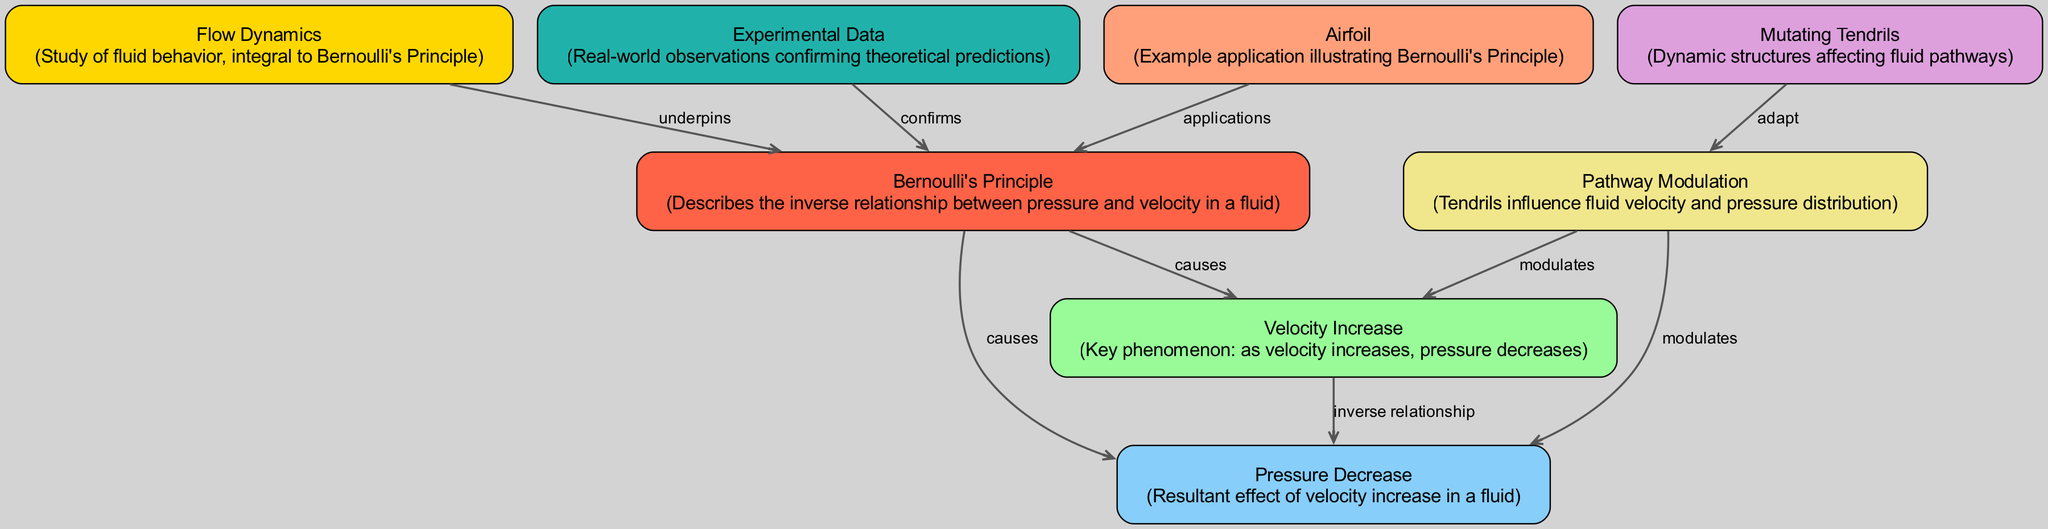What is the central concept illustrated by this diagram? The central concept is "Bernoulli's Principle," which describes the relationship between pressure and velocity in a fluid. This is indicated by node "2" labeled "Bernoulli's Principle".
Answer: Bernoulli's Principle How many nodes are present in the diagram? The diagram contains eight nodes, which are represented in the data provided. Each node corresponds to a different aspect of fluid dynamics associated with Bernoulli's Principle.
Answer: 8 What relationship does "Flow Dynamics" have with "Bernoulli's Principle"? "Flow Dynamics" underpins "Bernoulli's Principle," as indicated by the directed edge labeled "underpins" connecting node "1" to node "2". This edge signifies that the study of fluid behavior is foundational to understanding Bernoulli's Principle.
Answer: underpins What phenomenon occurs as velocity increases according to Bernoulli's Principle? As velocity increases, pressure decreases. This inverse relationship is explicitly stated between nodes "3" and "4" in the diagram with the edge labeled "inverse relationship".
Answer: pressure decreases Which node describes dynamic structures that affect fluid pathways? The node labeled "Mutating Tendrils" describes dynamic structures that influence fluid pathways. This is clearly indicated by node "5" in the diagram.
Answer: Mutating Tendrils How do the "Mutating Tendrils" affect fluid behavior? "Mutating Tendrils" adapt pathways, modulating both velocity and pressure distribution in the fluid. This is shown by the edges connecting node "5" to node "6", and then from node "6" to nodes "3" and "4".
Answer: influence fluid velocity and pressure distribution What confirms the theoretical predictions of Bernoulli's Principle in this diagram? The "Experimental Data" confirms the theoretical predictions of Bernoulli's Principle, as indicated by the edge from node "7" to node "2" labeled "confirms".
Answer: Experimental Data Which application is specifically mentioned as an example of Bernoulli's Principle? The application specifically mentioned is "Airfoil,” which illustrates how Bernoulli's Principle is used in practice, as shown in node "8".
Answer: Airfoil What effect does the "Pathway Modulation" have according to the diagram? "Pathway Modulation" modulates both velocity and pressure, affecting how the fluid behaves. This is represented by the edges going from node "6" to nodes "3" and "4".
Answer: modulates velocity and pressure 